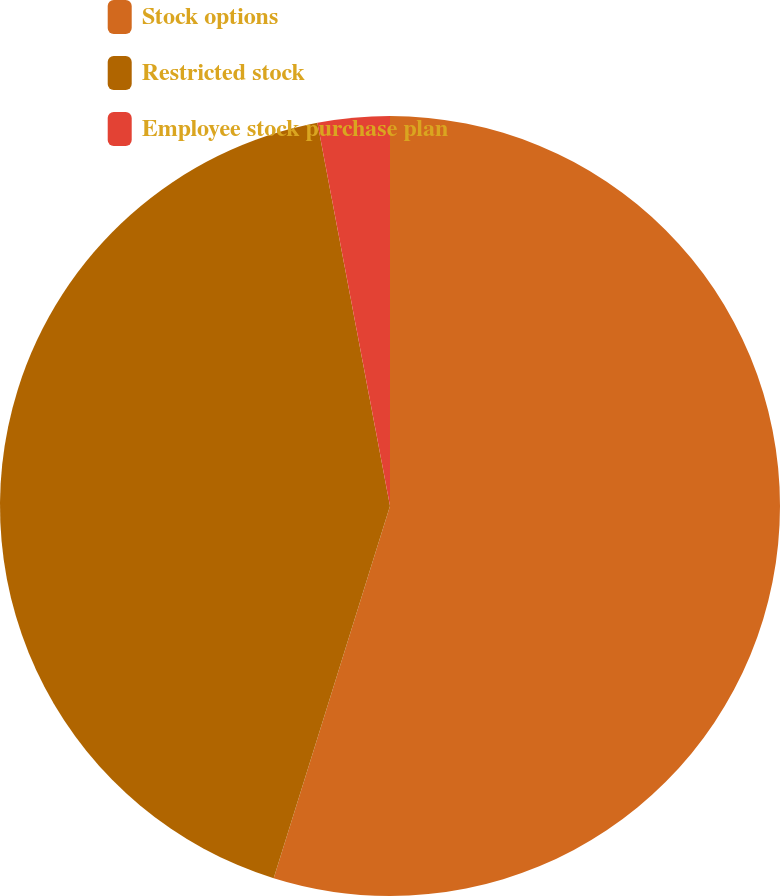Convert chart. <chart><loc_0><loc_0><loc_500><loc_500><pie_chart><fcel>Stock options<fcel>Restricted stock<fcel>Employee stock purchase plan<nl><fcel>54.82%<fcel>42.2%<fcel>2.98%<nl></chart> 